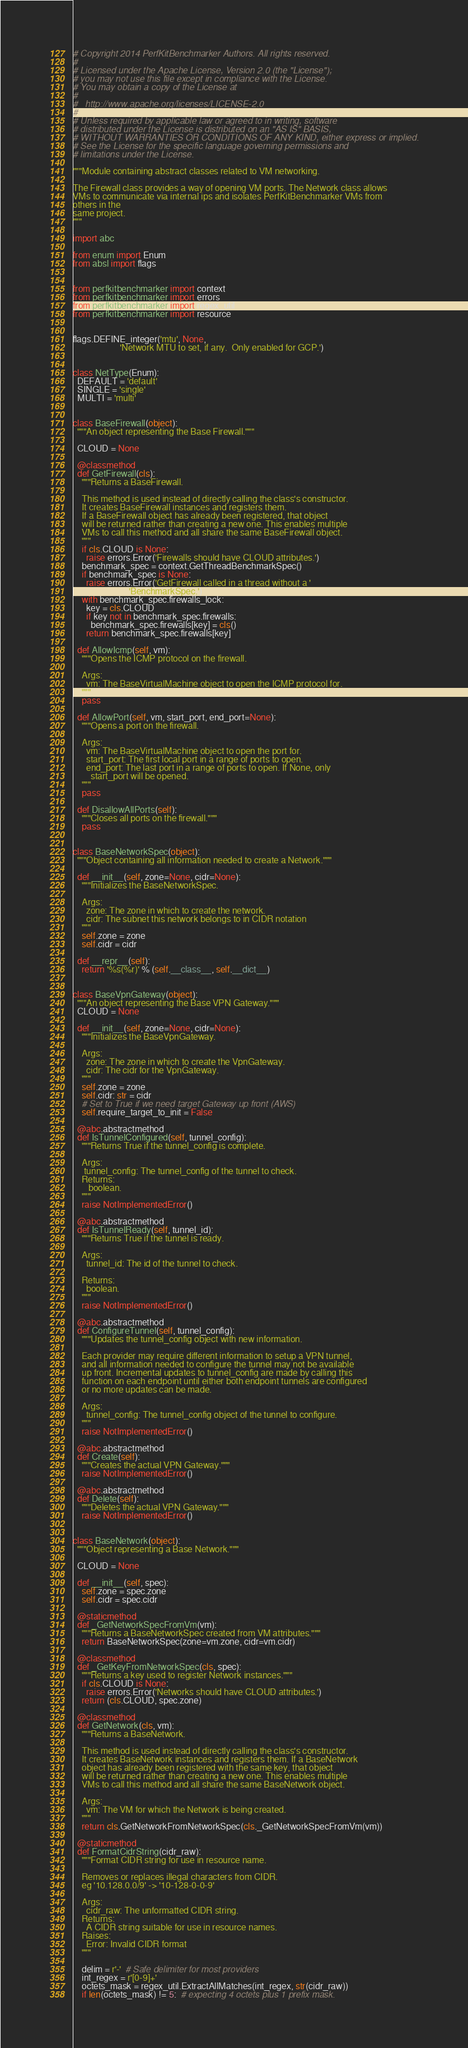Convert code to text. <code><loc_0><loc_0><loc_500><loc_500><_Python_># Copyright 2014 PerfKitBenchmarker Authors. All rights reserved.
#
# Licensed under the Apache License, Version 2.0 (the "License");
# you may not use this file except in compliance with the License.
# You may obtain a copy of the License at
#
#   http://www.apache.org/licenses/LICENSE-2.0
#
# Unless required by applicable law or agreed to in writing, software
# distributed under the License is distributed on an "AS IS" BASIS,
# WITHOUT WARRANTIES OR CONDITIONS OF ANY KIND, either express or implied.
# See the License for the specific language governing permissions and
# limitations under the License.

"""Module containing abstract classes related to VM networking.

The Firewall class provides a way of opening VM ports. The Network class allows
VMs to communicate via internal ips and isolates PerfKitBenchmarker VMs from
others in the
same project.
"""

import abc

from enum import Enum
from absl import flags


from perfkitbenchmarker import context
from perfkitbenchmarker import errors
from perfkitbenchmarker import regex_util
from perfkitbenchmarker import resource


flags.DEFINE_integer('mtu', None,
                     'Network MTU to set, if any.  Only enabled for GCP.')


class NetType(Enum):
  DEFAULT = 'default'
  SINGLE = 'single'
  MULTI = 'multi'


class BaseFirewall(object):
  """An object representing the Base Firewall."""

  CLOUD = None

  @classmethod
  def GetFirewall(cls):
    """Returns a BaseFirewall.

    This method is used instead of directly calling the class's constructor.
    It creates BaseFirewall instances and registers them.
    If a BaseFirewall object has already been registered, that object
    will be returned rather than creating a new one. This enables multiple
    VMs to call this method and all share the same BaseFirewall object.
    """
    if cls.CLOUD is None:
      raise errors.Error('Firewalls should have CLOUD attributes.')
    benchmark_spec = context.GetThreadBenchmarkSpec()
    if benchmark_spec is None:
      raise errors.Error('GetFirewall called in a thread without a '
                         'BenchmarkSpec.')
    with benchmark_spec.firewalls_lock:
      key = cls.CLOUD
      if key not in benchmark_spec.firewalls:
        benchmark_spec.firewalls[key] = cls()
      return benchmark_spec.firewalls[key]

  def AllowIcmp(self, vm):
    """Opens the ICMP protocol on the firewall.

    Args:
      vm: The BaseVirtualMachine object to open the ICMP protocol for.
    """
    pass

  def AllowPort(self, vm, start_port, end_port=None):
    """Opens a port on the firewall.

    Args:
      vm: The BaseVirtualMachine object to open the port for.
      start_port: The first local port in a range of ports to open.
      end_port: The last port in a range of ports to open. If None, only
        start_port will be opened.
    """
    pass

  def DisallowAllPorts(self):
    """Closes all ports on the firewall."""
    pass


class BaseNetworkSpec(object):
  """Object containing all information needed to create a Network."""

  def __init__(self, zone=None, cidr=None):
    """Initializes the BaseNetworkSpec.

    Args:
      zone: The zone in which to create the network.
      cidr: The subnet this network belongs to in CIDR notation
    """
    self.zone = zone
    self.cidr = cidr

  def __repr__(self):
    return '%s(%r)' % (self.__class__, self.__dict__)


class BaseVpnGateway(object):
  """An object representing the Base VPN Gateway."""
  CLOUD = None

  def __init__(self, zone=None, cidr=None):
    """Initializes the BaseVpnGateway.

    Args:
      zone: The zone in which to create the VpnGateway.
      cidr: The cidr for the VpnGateway.
    """
    self.zone = zone
    self.cidr: str = cidr
    # Set to True if we need target Gateway up front (AWS)
    self.require_target_to_init = False

  @abc.abstractmethod
  def IsTunnelConfigured(self, tunnel_config):
    """Returns True if the tunnel_config is complete.

    Args:
     tunnel_config: The tunnel_config of the tunnel to check.
    Returns:
       boolean.
    """
    raise NotImplementedError()

  @abc.abstractmethod
  def IsTunnelReady(self, tunnel_id):
    """Returns True if the tunnel is ready.

    Args:
      tunnel_id: The id of the tunnel to check.

    Returns:
      boolean.
    """
    raise NotImplementedError()

  @abc.abstractmethod
  def ConfigureTunnel(self, tunnel_config):
    """Updates the tunnel_config object with new information.

    Each provider may require different information to setup a VPN tunnel,
    and all information needed to configure the tunnel may not be available
    up front. Incremental updates to tunnel_config are made by calling this
    function on each endpoint until either both endpoint tunnels are configured
    or no more updates can be made.

    Args:
      tunnel_config: The tunnel_config object of the tunnel to configure.
    """
    raise NotImplementedError()

  @abc.abstractmethod
  def Create(self):
    """Creates the actual VPN Gateway."""
    raise NotImplementedError()

  @abc.abstractmethod
  def Delete(self):
    """Deletes the actual VPN Gateway."""
    raise NotImplementedError()


class BaseNetwork(object):
  """Object representing a Base Network."""

  CLOUD = None

  def __init__(self, spec):
    self.zone = spec.zone
    self.cidr = spec.cidr

  @staticmethod
  def _GetNetworkSpecFromVm(vm):
    """Returns a BaseNetworkSpec created from VM attributes."""
    return BaseNetworkSpec(zone=vm.zone, cidr=vm.cidr)

  @classmethod
  def _GetKeyFromNetworkSpec(cls, spec):
    """Returns a key used to register Network instances."""
    if cls.CLOUD is None:
      raise errors.Error('Networks should have CLOUD attributes.')
    return (cls.CLOUD, spec.zone)

  @classmethod
  def GetNetwork(cls, vm):
    """Returns a BaseNetwork.

    This method is used instead of directly calling the class's constructor.
    It creates BaseNetwork instances and registers them. If a BaseNetwork
    object has already been registered with the same key, that object
    will be returned rather than creating a new one. This enables multiple
    VMs to call this method and all share the same BaseNetwork object.

    Args:
      vm: The VM for which the Network is being created.
    """
    return cls.GetNetworkFromNetworkSpec(cls._GetNetworkSpecFromVm(vm))

  @staticmethod
  def FormatCidrString(cidr_raw):
    """Format CIDR string for use in resource name.

    Removes or replaces illegal characters from CIDR.
    eg '10.128.0.0/9' -> '10-128-0-0-9'

    Args:
      cidr_raw: The unformatted CIDR string.
    Returns:
      A CIDR string suitable for use in resource names.
    Raises:
      Error: Invalid CIDR format
    """

    delim = r'-'  # Safe delimiter for most providers
    int_regex = r'[0-9]+'
    octets_mask = regex_util.ExtractAllMatches(int_regex, str(cidr_raw))
    if len(octets_mask) != 5:  # expecting 4 octets plus 1 prefix mask.</code> 